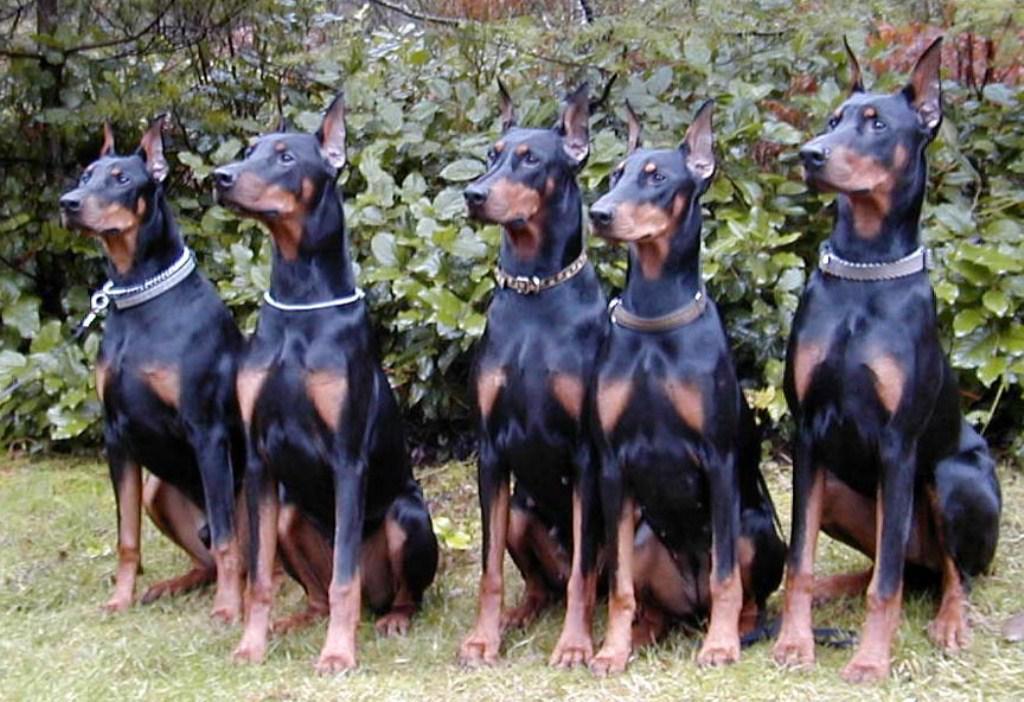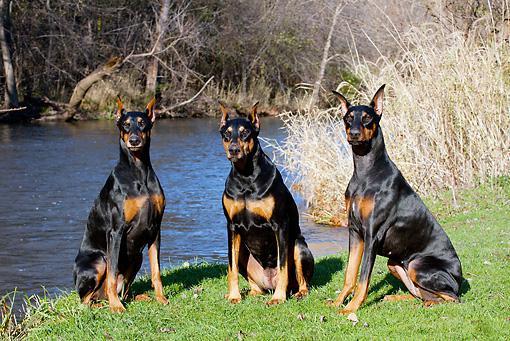The first image is the image on the left, the second image is the image on the right. For the images shown, is this caption "At least one image features a doberman sitting upright in autumn foliage, and all dobermans are in some pose on autumn foilage." true? Answer yes or no. No. The first image is the image on the left, the second image is the image on the right. For the images shown, is this caption "The dogs are all sitting in leaves." true? Answer yes or no. No. 